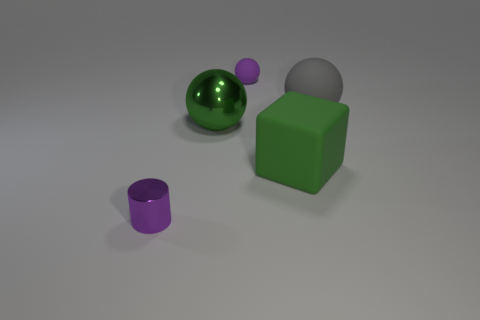Is the color of the cube the same as the metallic sphere?
Offer a very short reply. Yes. There is a big ball that is in front of the gray sphere; what is its material?
Provide a short and direct response. Metal. There is a object that is left of the green block and behind the metallic ball; what shape is it?
Make the answer very short. Sphere. What is the material of the cylinder in front of the shiny thing that is behind the object to the left of the large green metal sphere?
Provide a succinct answer. Metal. There is a small shiny object that is in front of the green matte cube; how many tiny balls are behind it?
Provide a succinct answer. 1. There is a big metallic object that is the same shape as the large gray matte object; what is its color?
Your answer should be compact. Green. Are the purple cylinder and the small purple sphere made of the same material?
Ensure brevity in your answer.  No. What is the size of the purple object behind the tiny object left of the purple thing behind the green shiny object?
Make the answer very short. Small. There is a purple matte thing that is the same shape as the big gray object; what size is it?
Offer a terse response. Small. Do the small object that is to the left of the green metallic thing and the tiny rubber ball have the same color?
Provide a succinct answer. Yes. 